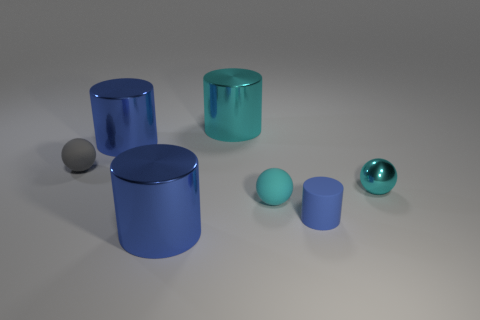How many other things are there of the same color as the shiny ball?
Your answer should be compact. 2. There is a rubber ball in front of the cyan metal sphere; does it have the same size as the sphere that is on the left side of the small cyan matte ball?
Your response must be concise. Yes. Is the material of the small blue thing the same as the blue cylinder behind the metal sphere?
Make the answer very short. No. Are there more shiny cylinders on the right side of the cyan rubber ball than large cylinders that are in front of the cyan metal cylinder?
Your answer should be very brief. No. What is the color of the big thing behind the large blue shiny cylinder that is behind the tiny gray sphere?
Ensure brevity in your answer.  Cyan. How many blocks are tiny blue matte things or large cyan objects?
Ensure brevity in your answer.  0. What number of metal objects are both in front of the metallic sphere and behind the cyan metallic sphere?
Ensure brevity in your answer.  0. The tiny matte ball that is behind the tiny shiny object is what color?
Ensure brevity in your answer.  Gray. There is a cyan sphere that is the same material as the tiny cylinder; what is its size?
Offer a very short reply. Small. What number of big blue metallic cylinders are in front of the sphere that is left of the big cyan metallic object?
Offer a terse response. 1. 